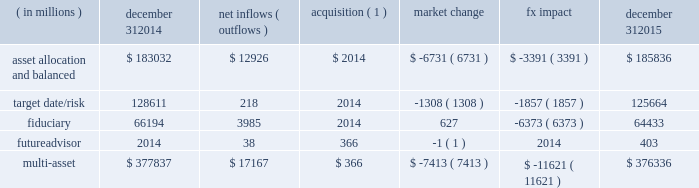Long-term product offerings include active and index strategies .
Our active strategies seek to earn attractive returns in excess of a market benchmark or performance hurdle while maintaining an appropriate risk profile .
We offer two types of active strategies : those that rely primarily on fundamental research and those that utilize primarily quantitative models to drive portfolio construction .
In contrast , index strategies seek to closely track the returns of a corresponding index , generally by investing in substantially the same underlying securities within the index or in a subset of those securities selected to approximate a similar risk and return profile of the index .
Index strategies include both our non-etf index products and ishares etfs .
Althoughmany clients use both active and index strategies , the application of these strategies may differ .
For example , clients may use index products to gain exposure to a market or asset class .
In addition , institutional non-etf index assignments tend to be very large ( multi-billion dollars ) and typically reflect low fee rates .
This has the potential to exaggerate the significance of net flows in institutional index products on blackrock 2019s revenues and earnings .
Equity year-end 2015 equity aum totaled $ 2.424 trillion , reflecting net inflows of $ 52.8 billion .
Net inflows included $ 78.4 billion and $ 4.2 billion into ishares and active products , respectively .
Ishares net inflows were driven by the core series and flows into broad developed market equity exposures , and active net inflows reflected demand for international equities .
Ishares and active net inflows were partially offset by non-etf index net outflows of $ 29.8 billion .
Blackrock 2019s effective fee rates fluctuate due to changes in aummix .
Approximately half of blackrock 2019s equity aum is tied to international markets , including emerging markets , which tend to have higher fee rates than u.s .
Equity strategies .
Accordingly , fluctuations in international equity markets , which do not consistently move in tandemwith u.s .
Markets , may have a greater impact on blackrock 2019s effective equity fee rates and revenues .
Fixed income fixed income aum ended 2015 at $ 1.422 trillion , increasing $ 28.7 billion , or 2% ( 2 % ) , from december 31 , 2014 .
The increase in aum reflected $ 76.9 billion in net inflows , partially offset by $ 48.2 billion in net market depreciation and foreign exchange movements .
In 2015 , active net inflows of $ 35.9 billion were diversified across fixed income offerings , with strong flows into our unconstrained , total return and high yield strategies .
Flagship funds in these product areas include our unconstrained strategic income opportunities and fixed income strategies funds , with net inflows of $ 7.0 billion and $ 3.7 billion , respectively ; our total return fund with net inflows of $ 2.7 billion ; and our high yield bond fund with net inflows of $ 3.5 billion .
Fixed income ishares net inflows of $ 50.3 billion were led by flows into core , corporate and high yield bond funds .
Active and ishares net inflows were partially offset by non-etf index net outflows of $ 9.3 billion .
Multi-asset class blackrock 2019s multi-asset class teammanages a variety of balanced funds and bespoke mandates for a diversified client base that leverages our broad investment expertise in global equities , bonds , currencies and commodities , and our extensive risk management capabilities .
Investment solutions might include a combination of long-only portfolios and alternative investments as well as tactical asset allocation overlays .
Component changes in multi-asset class aum for 2015 are presented below .
( in millions ) december 31 , 2014 net inflows ( outflows ) acquisition ( 1 ) market change fx impact december 31 , 2015 asset allocation and balanced $ 183032 $ 12926 $ 2014 $ ( 6731 ) $ ( 3391 ) $ 185836 .
( 1 ) amounts represent $ 366 million of aum acquired in the futureadvisor acquisition in october 2015 .
The futureadvisor acquisition amount does not include aum that was held in ishares holdings .
Multi-asset class net inflows reflected ongoing institutional demand for our solutions-based advice with $ 17.4 billion of net inflows coming from institutional clients .
Defined contribution plans of institutional clients remained a significant driver of flows , and contributed $ 7.3 billion to institutional multi-asset class net new business in 2015 , primarily into target date and target risk product offerings .
Retail net outflows of $ 1.3 billion were primarily due to a large single-client transition out of mutual funds into a series of ishares across asset classes .
Notwithstanding this transition , retail flows reflected demand for our multi-asset income fund family , which raised $ 4.6 billion in 2015 .
The company 2019s multi-asset class strategies include the following : 2022 asset allocation and balanced products represented 49% ( 49 % ) of multi-asset class aum at year-end , with growth in aum driven by net new business of $ 12.9 billion .
These strategies combine equity , fixed income and alternative components for investors seeking a tailored solution relative to a specific benchmark and within a risk budget .
In certain cases , these strategies seek to minimize downside risk through diversification , derivatives strategies and tactical asset allocation decisions .
Flagship products in this category include our global allocation andmulti-asset income suites. .
What percent of the muilti asset value is from the asset allocation and balanced section? 
Computations: (185836 / 376336)
Answer: 0.4938. Long-term product offerings include active and index strategies .
Our active strategies seek to earn attractive returns in excess of a market benchmark or performance hurdle while maintaining an appropriate risk profile .
We offer two types of active strategies : those that rely primarily on fundamental research and those that utilize primarily quantitative models to drive portfolio construction .
In contrast , index strategies seek to closely track the returns of a corresponding index , generally by investing in substantially the same underlying securities within the index or in a subset of those securities selected to approximate a similar risk and return profile of the index .
Index strategies include both our non-etf index products and ishares etfs .
Althoughmany clients use both active and index strategies , the application of these strategies may differ .
For example , clients may use index products to gain exposure to a market or asset class .
In addition , institutional non-etf index assignments tend to be very large ( multi-billion dollars ) and typically reflect low fee rates .
This has the potential to exaggerate the significance of net flows in institutional index products on blackrock 2019s revenues and earnings .
Equity year-end 2015 equity aum totaled $ 2.424 trillion , reflecting net inflows of $ 52.8 billion .
Net inflows included $ 78.4 billion and $ 4.2 billion into ishares and active products , respectively .
Ishares net inflows were driven by the core series and flows into broad developed market equity exposures , and active net inflows reflected demand for international equities .
Ishares and active net inflows were partially offset by non-etf index net outflows of $ 29.8 billion .
Blackrock 2019s effective fee rates fluctuate due to changes in aummix .
Approximately half of blackrock 2019s equity aum is tied to international markets , including emerging markets , which tend to have higher fee rates than u.s .
Equity strategies .
Accordingly , fluctuations in international equity markets , which do not consistently move in tandemwith u.s .
Markets , may have a greater impact on blackrock 2019s effective equity fee rates and revenues .
Fixed income fixed income aum ended 2015 at $ 1.422 trillion , increasing $ 28.7 billion , or 2% ( 2 % ) , from december 31 , 2014 .
The increase in aum reflected $ 76.9 billion in net inflows , partially offset by $ 48.2 billion in net market depreciation and foreign exchange movements .
In 2015 , active net inflows of $ 35.9 billion were diversified across fixed income offerings , with strong flows into our unconstrained , total return and high yield strategies .
Flagship funds in these product areas include our unconstrained strategic income opportunities and fixed income strategies funds , with net inflows of $ 7.0 billion and $ 3.7 billion , respectively ; our total return fund with net inflows of $ 2.7 billion ; and our high yield bond fund with net inflows of $ 3.5 billion .
Fixed income ishares net inflows of $ 50.3 billion were led by flows into core , corporate and high yield bond funds .
Active and ishares net inflows were partially offset by non-etf index net outflows of $ 9.3 billion .
Multi-asset class blackrock 2019s multi-asset class teammanages a variety of balanced funds and bespoke mandates for a diversified client base that leverages our broad investment expertise in global equities , bonds , currencies and commodities , and our extensive risk management capabilities .
Investment solutions might include a combination of long-only portfolios and alternative investments as well as tactical asset allocation overlays .
Component changes in multi-asset class aum for 2015 are presented below .
( in millions ) december 31 , 2014 net inflows ( outflows ) acquisition ( 1 ) market change fx impact december 31 , 2015 asset allocation and balanced $ 183032 $ 12926 $ 2014 $ ( 6731 ) $ ( 3391 ) $ 185836 .
( 1 ) amounts represent $ 366 million of aum acquired in the futureadvisor acquisition in october 2015 .
The futureadvisor acquisition amount does not include aum that was held in ishares holdings .
Multi-asset class net inflows reflected ongoing institutional demand for our solutions-based advice with $ 17.4 billion of net inflows coming from institutional clients .
Defined contribution plans of institutional clients remained a significant driver of flows , and contributed $ 7.3 billion to institutional multi-asset class net new business in 2015 , primarily into target date and target risk product offerings .
Retail net outflows of $ 1.3 billion were primarily due to a large single-client transition out of mutual funds into a series of ishares across asset classes .
Notwithstanding this transition , retail flows reflected demand for our multi-asset income fund family , which raised $ 4.6 billion in 2015 .
The company 2019s multi-asset class strategies include the following : 2022 asset allocation and balanced products represented 49% ( 49 % ) of multi-asset class aum at year-end , with growth in aum driven by net new business of $ 12.9 billion .
These strategies combine equity , fixed income and alternative components for investors seeking a tailored solution relative to a specific benchmark and within a risk budget .
In certain cases , these strategies seek to minimize downside risk through diversification , derivatives strategies and tactical asset allocation decisions .
Flagship products in this category include our global allocation andmulti-asset income suites. .
What is the growth rate in the balance of asset allocation from 2014 to 2015? 
Computations: ((185836 - 183032) / 183032)
Answer: 0.01532. 